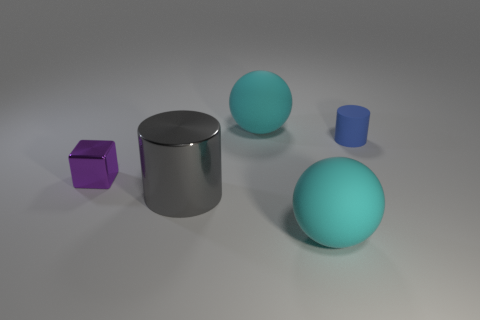Add 5 big cyan matte objects. How many objects exist? 10 Subtract all spheres. How many objects are left? 3 Add 1 small purple objects. How many small purple objects are left? 2 Add 4 cyan matte objects. How many cyan matte objects exist? 6 Subtract 0 red balls. How many objects are left? 5 Subtract all cyan blocks. Subtract all blue cylinders. How many blocks are left? 1 Subtract all small purple cubes. Subtract all shiny balls. How many objects are left? 4 